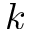Convert formula to latex. <formula><loc_0><loc_0><loc_500><loc_500>k</formula> 